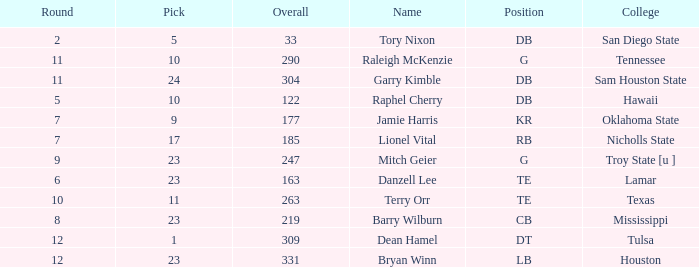How many Picks have an Overall smaller than 304, and a Position of g, and a Round smaller than 11? 1.0. 